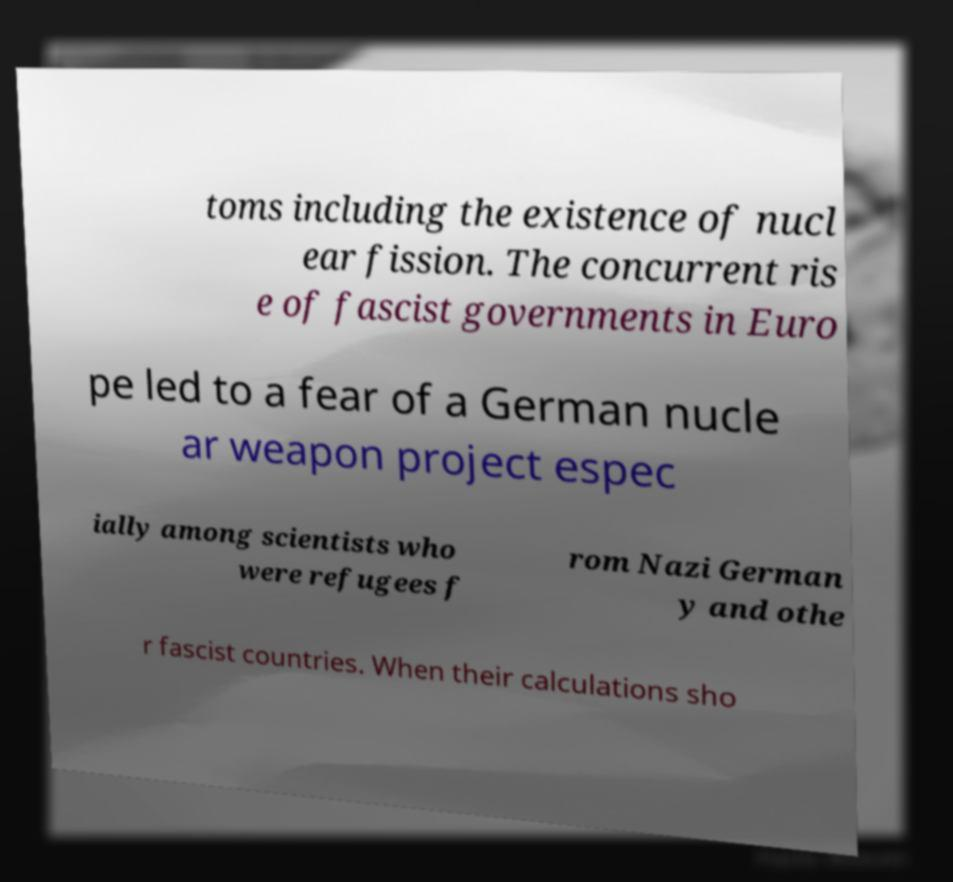What messages or text are displayed in this image? I need them in a readable, typed format. toms including the existence of nucl ear fission. The concurrent ris e of fascist governments in Euro pe led to a fear of a German nucle ar weapon project espec ially among scientists who were refugees f rom Nazi German y and othe r fascist countries. When their calculations sho 